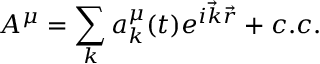<formula> <loc_0><loc_0><loc_500><loc_500>A ^ { \mu } = \sum _ { k } a _ { k } ^ { \mu } ( t ) e ^ { i { \vec { k } } { \vec { r } } } + c . c .</formula> 